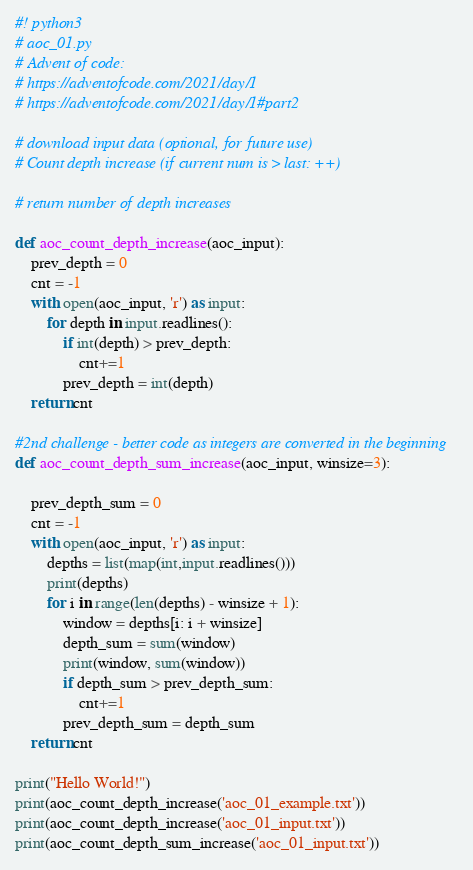<code> <loc_0><loc_0><loc_500><loc_500><_Python_>#! python3
# aoc_01.py
# Advent of code:
# https://adventofcode.com/2021/day/1
# https://adventofcode.com/2021/day/1#part2

# download input data (optional, for future use)
# Count depth increase (if current num is > last: ++)

# return number of depth increases

def aoc_count_depth_increase(aoc_input):
    prev_depth = 0
    cnt = -1
    with open(aoc_input, 'r') as input:
        for depth in input.readlines():
            if int(depth) > prev_depth:
                cnt+=1
            prev_depth = int(depth)
    return cnt

#2nd challenge - better code as integers are converted in the beginning
def aoc_count_depth_sum_increase(aoc_input, winsize=3):

    prev_depth_sum = 0
    cnt = -1
    with open(aoc_input, 'r') as input:
        depths = list(map(int,input.readlines()))
        print(depths)
        for i in range(len(depths) - winsize + 1):
            window = depths[i: i + winsize]
            depth_sum = sum(window)
            print(window, sum(window))
            if depth_sum > prev_depth_sum:
                cnt+=1
            prev_depth_sum = depth_sum
    return cnt

print("Hello World!")
print(aoc_count_depth_increase('aoc_01_example.txt'))
print(aoc_count_depth_increase('aoc_01_input.txt'))
print(aoc_count_depth_sum_increase('aoc_01_input.txt'))

</code> 